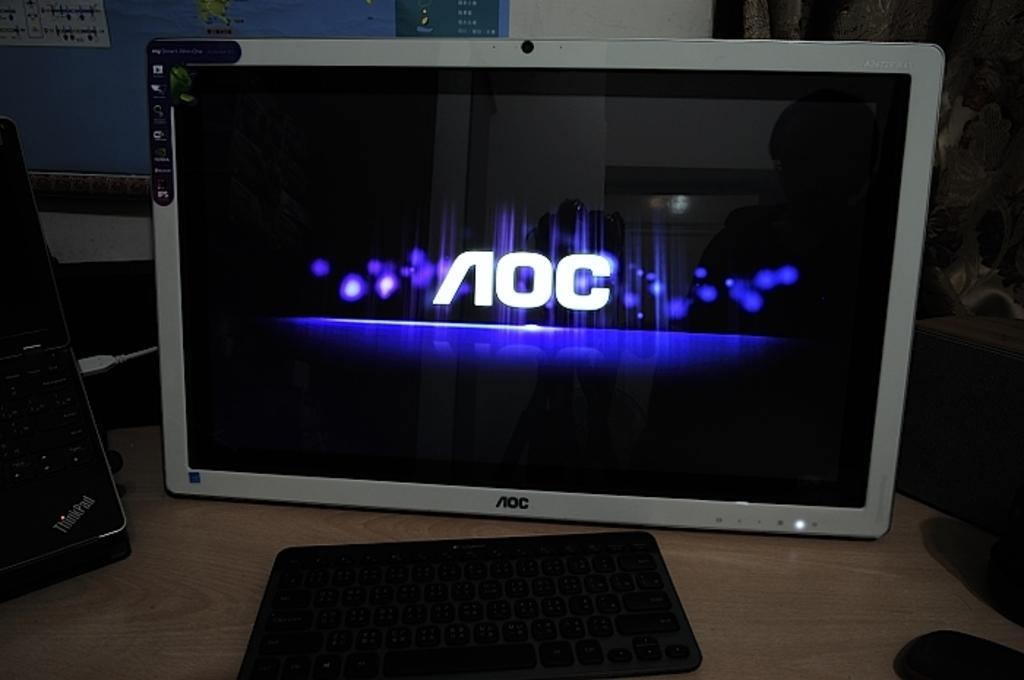In one or two sentences, can you explain what this image depicts? In this picture I can see a monitor on which something displaying on it. I can also see keyboard and other objects on the table. In the background I can see a wall. 